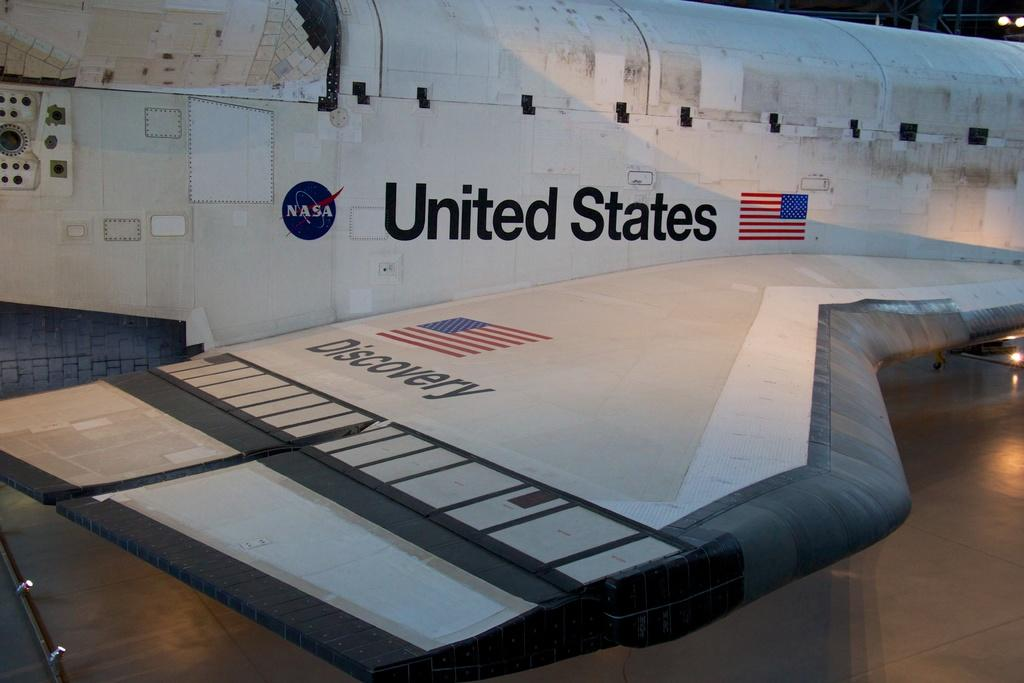Provide a one-sentence caption for the provided image. Parked airplace that has "United States" on the side. 